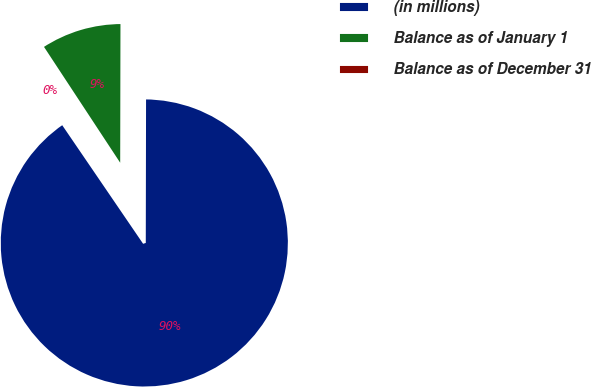Convert chart. <chart><loc_0><loc_0><loc_500><loc_500><pie_chart><fcel>(in millions)<fcel>Balance as of January 1<fcel>Balance as of December 31<nl><fcel>90.44%<fcel>9.29%<fcel>0.27%<nl></chart> 